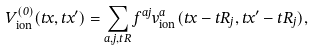<formula> <loc_0><loc_0><loc_500><loc_500>V _ { \text {ion} } ^ { ( 0 ) } ( \vec { t } { x } , \vec { t } { x } ^ { \prime } ) = \sum _ { a , j , \vec { t } { R } } f ^ { a j } v ^ { a } _ { \text {ion} } ( \vec { t } { x } - \vec { t } { R } _ { j } , \vec { t } { x } ^ { \prime } - \vec { t } { R } _ { j } ) ,</formula> 